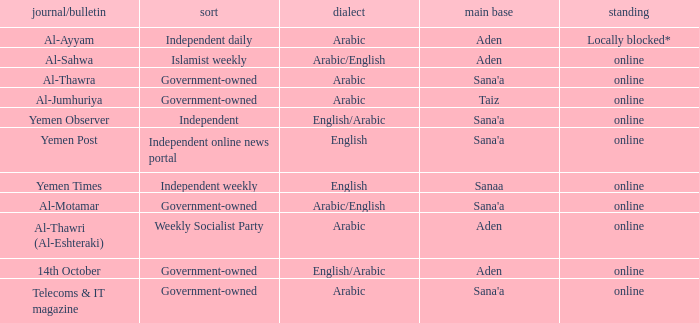I'm looking to parse the entire table for insights. Could you assist me with that? {'header': ['journal/bulletin', 'sort', 'dialect', 'main base', 'standing'], 'rows': [['Al-Ayyam', 'Independent daily', 'Arabic', 'Aden', 'Locally blocked*'], ['Al-Sahwa', 'Islamist weekly', 'Arabic/English', 'Aden', 'online'], ['Al-Thawra', 'Government-owned', 'Arabic', "Sana'a", 'online'], ['Al-Jumhuriya', 'Government-owned', 'Arabic', 'Taiz', 'online'], ['Yemen Observer', 'Independent', 'English/Arabic', "Sana'a", 'online'], ['Yemen Post', 'Independent online news portal', 'English', "Sana'a", 'online'], ['Yemen Times', 'Independent weekly', 'English', 'Sanaa', 'online'], ['Al-Motamar', 'Government-owned', 'Arabic/English', "Sana'a", 'online'], ['Al-Thawri (Al-Eshteraki)', 'Weekly Socialist Party', 'Arabic', 'Aden', 'online'], ['14th October', 'Government-owned', 'English/Arabic', 'Aden', 'online'], ['Telecoms & IT magazine', 'Government-owned', 'Arabic', "Sana'a", 'online']]} What is Headquarter, when Type is Independent Online News Portal? Sana'a. 